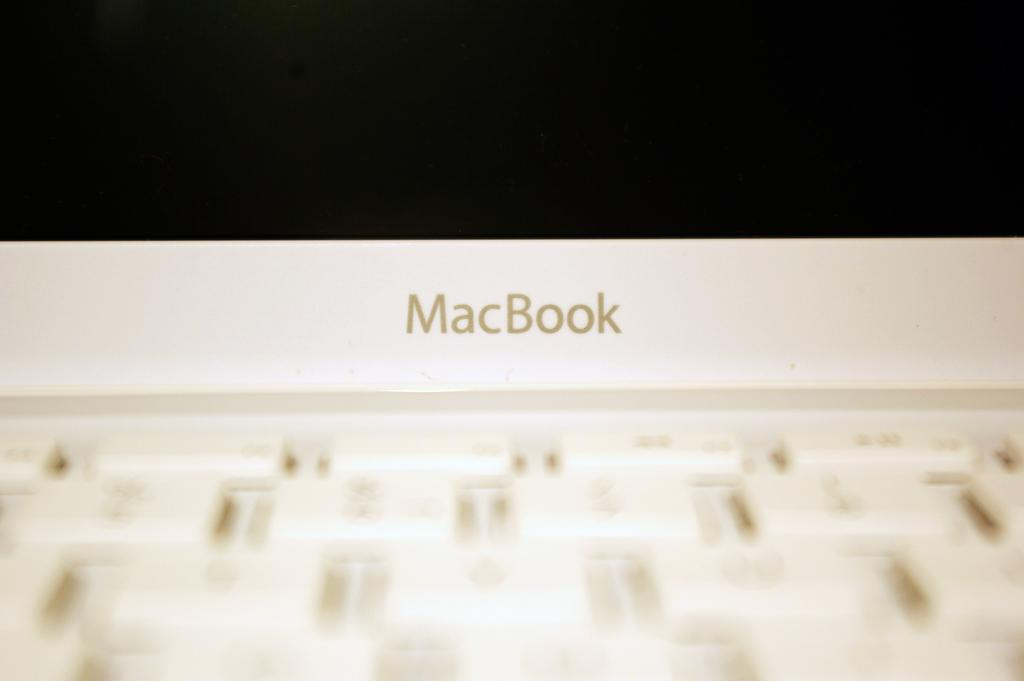What device is present in the image that allows for input? There is a keypad in the image. What device is present in the image that displays information? There is a monitor in the image. What can be seen on the monitor in the image? The monitor displays some text. What type of tooth is visible in the image? There is no tooth present in the image. Is there a church depicted in the image? No, there is no church present in the image. 